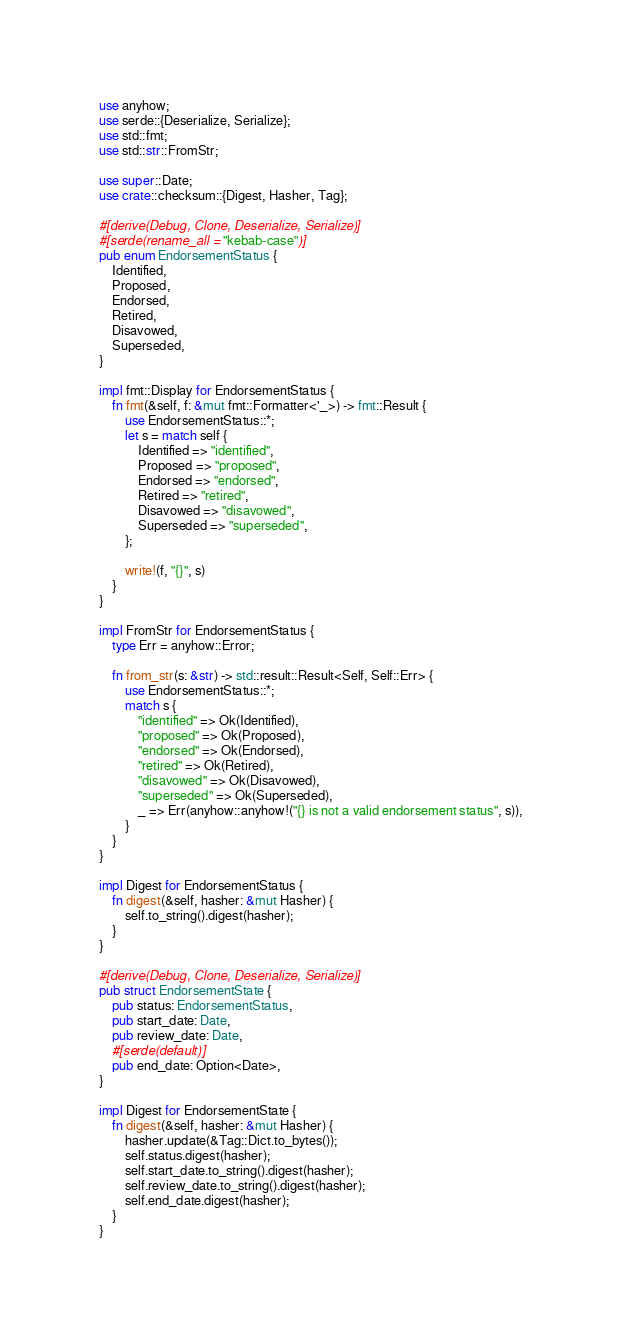<code> <loc_0><loc_0><loc_500><loc_500><_Rust_>use anyhow;
use serde::{Deserialize, Serialize};
use std::fmt;
use std::str::FromStr;

use super::Date;
use crate::checksum::{Digest, Hasher, Tag};

#[derive(Debug, Clone, Deserialize, Serialize)]
#[serde(rename_all = "kebab-case")]
pub enum EndorsementStatus {
    Identified,
    Proposed,
    Endorsed,
    Retired,
    Disavowed,
    Superseded,
}

impl fmt::Display for EndorsementStatus {
    fn fmt(&self, f: &mut fmt::Formatter<'_>) -> fmt::Result {
        use EndorsementStatus::*;
        let s = match self {
            Identified => "identified",
            Proposed => "proposed",
            Endorsed => "endorsed",
            Retired => "retired",
            Disavowed => "disavowed",
            Superseded => "superseded",
        };

        write!(f, "{}", s)
    }
}

impl FromStr for EndorsementStatus {
    type Err = anyhow::Error;

    fn from_str(s: &str) -> std::result::Result<Self, Self::Err> {
        use EndorsementStatus::*;
        match s {
            "identified" => Ok(Identified),
            "proposed" => Ok(Proposed),
            "endorsed" => Ok(Endorsed),
            "retired" => Ok(Retired),
            "disavowed" => Ok(Disavowed),
            "superseded" => Ok(Superseded),
            _ => Err(anyhow::anyhow!("{} is not a valid endorsement status", s)),
        }
    }
}

impl Digest for EndorsementStatus {
    fn digest(&self, hasher: &mut Hasher) {
        self.to_string().digest(hasher);
    }
}

#[derive(Debug, Clone, Deserialize, Serialize)]
pub struct EndorsementState {
    pub status: EndorsementStatus,
    pub start_date: Date,
    pub review_date: Date,
    #[serde(default)]
    pub end_date: Option<Date>,
}

impl Digest for EndorsementState {
    fn digest(&self, hasher: &mut Hasher) {
        hasher.update(&Tag::Dict.to_bytes());
        self.status.digest(hasher);
        self.start_date.to_string().digest(hasher);
        self.review_date.to_string().digest(hasher);
        self.end_date.digest(hasher);
    }
}
</code> 